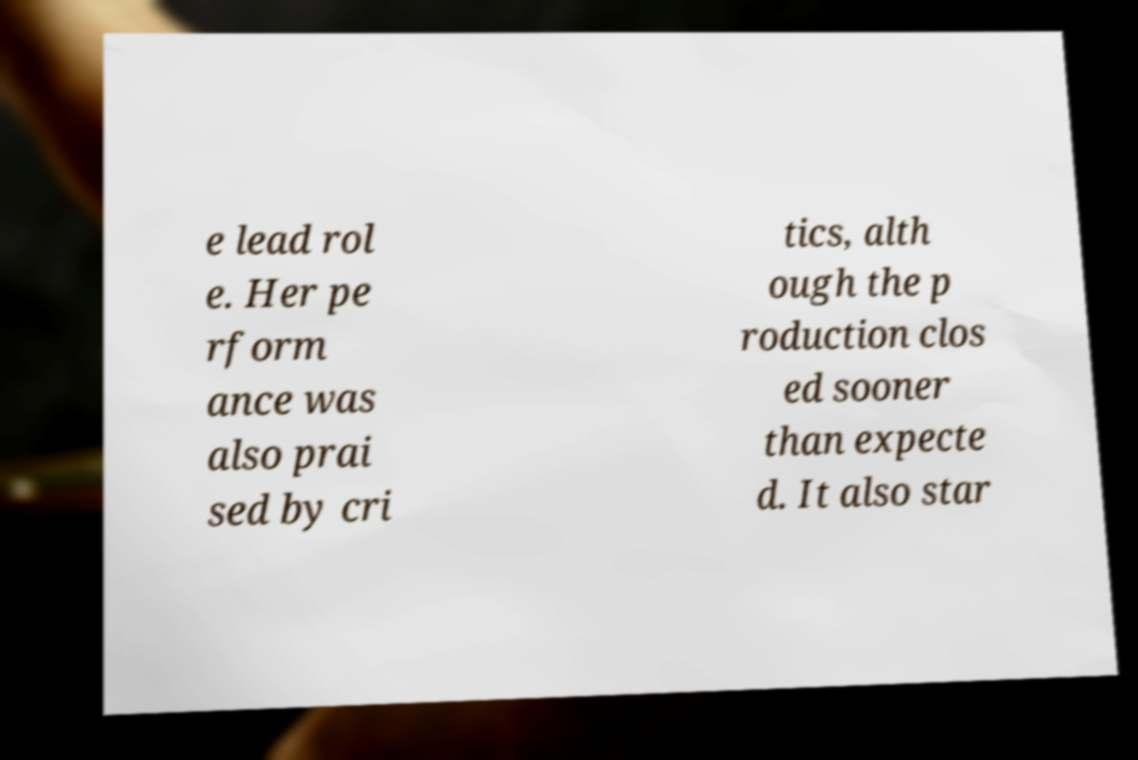I need the written content from this picture converted into text. Can you do that? e lead rol e. Her pe rform ance was also prai sed by cri tics, alth ough the p roduction clos ed sooner than expecte d. It also star 